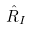Convert formula to latex. <formula><loc_0><loc_0><loc_500><loc_500>\hat { R } _ { I }</formula> 